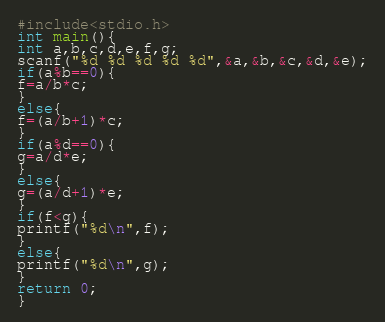<code> <loc_0><loc_0><loc_500><loc_500><_C_>#include<stdio.h>
int main(){
int a,b,c,d,e,f,g;
scanf("%d %d %d %d %d",&a,&b,&c,&d,&e);
if(a%b==0){
f=a/b*c;
}
else{
f=(a/b+1)*c;
}
if(a%d==0){
g=a/d*e;
}
else{
g=(a/d+1)*e;
}
if(f<g){
printf("%d\n",f);
}
else{
printf("%d\n",g);
}
return 0;
}
</code> 